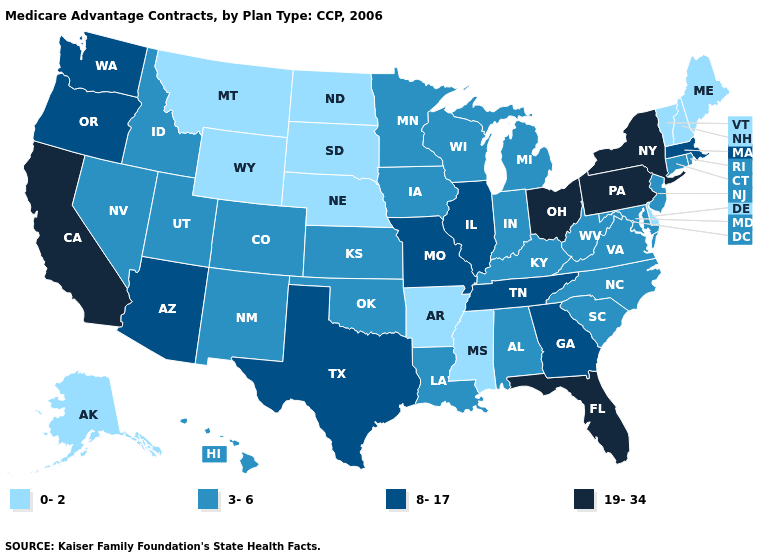What is the value of Pennsylvania?
Write a very short answer. 19-34. What is the value of Texas?
Concise answer only. 8-17. Which states have the lowest value in the South?
Keep it brief. Arkansas, Delaware, Mississippi. What is the value of Connecticut?
Answer briefly. 3-6. What is the value of Georgia?
Give a very brief answer. 8-17. Does Pennsylvania have a higher value than Iowa?
Quick response, please. Yes. Does the map have missing data?
Short answer required. No. What is the highest value in the USA?
Be succinct. 19-34. Does Connecticut have a lower value than Michigan?
Write a very short answer. No. What is the value of New Mexico?
Concise answer only. 3-6. Name the states that have a value in the range 8-17?
Quick response, please. Arizona, Georgia, Illinois, Massachusetts, Missouri, Oregon, Tennessee, Texas, Washington. Name the states that have a value in the range 19-34?
Quick response, please. California, Florida, New York, Ohio, Pennsylvania. Name the states that have a value in the range 0-2?
Give a very brief answer. Alaska, Arkansas, Delaware, Maine, Mississippi, Montana, North Dakota, Nebraska, New Hampshire, South Dakota, Vermont, Wyoming. What is the value of Arkansas?
Write a very short answer. 0-2. What is the value of Colorado?
Give a very brief answer. 3-6. 